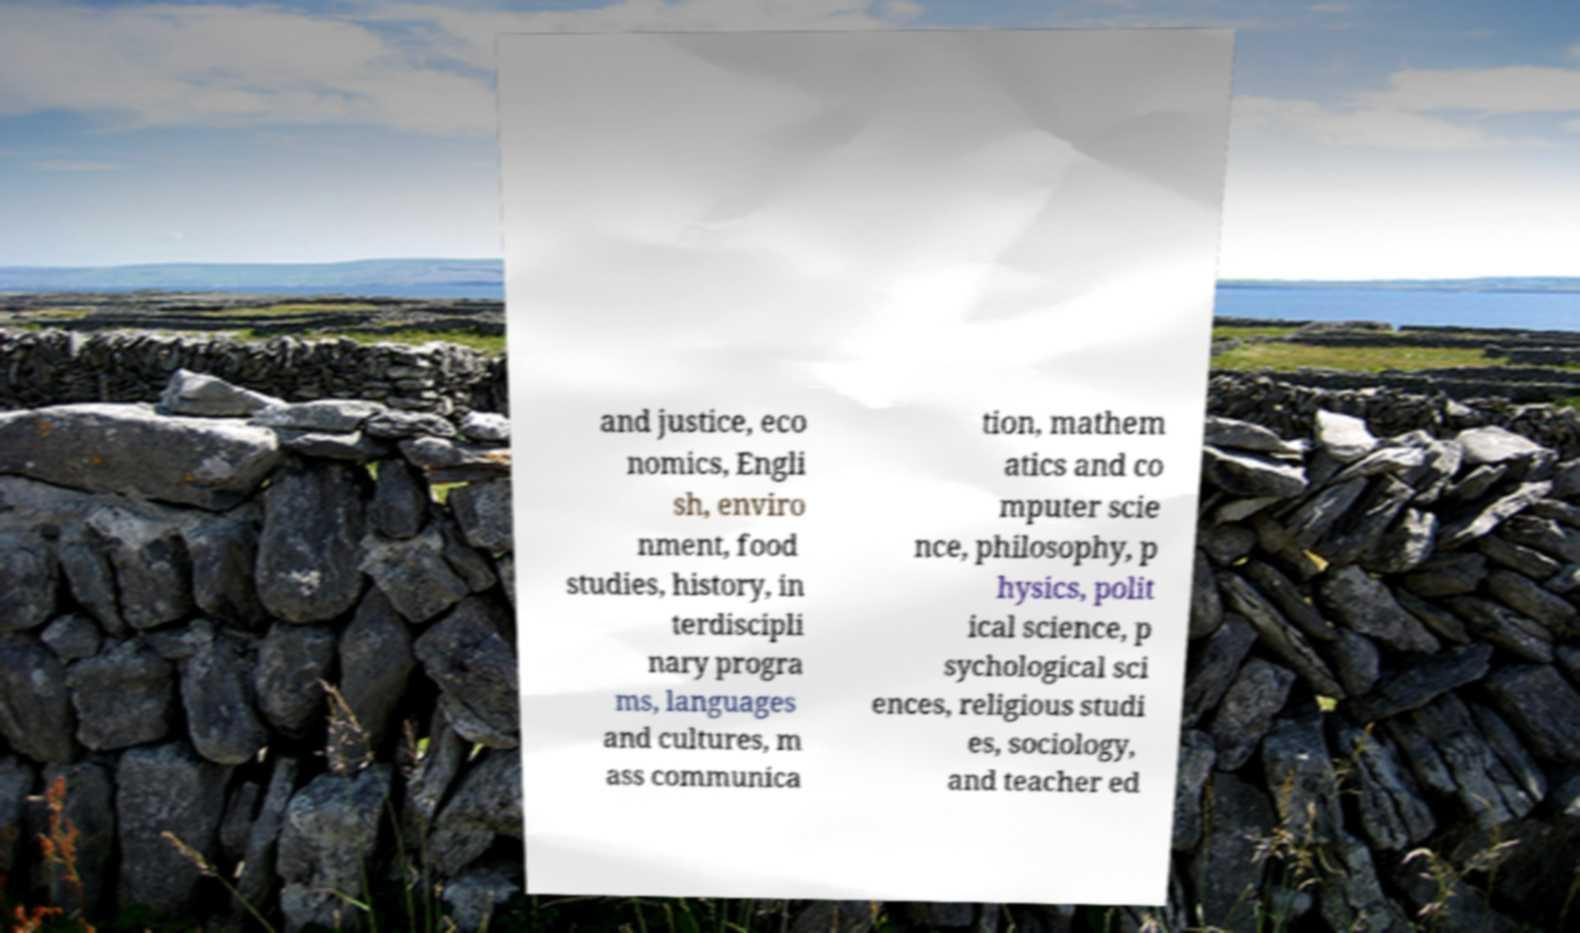Can you accurately transcribe the text from the provided image for me? and justice, eco nomics, Engli sh, enviro nment, food studies, history, in terdiscipli nary progra ms, languages and cultures, m ass communica tion, mathem atics and co mputer scie nce, philosophy, p hysics, polit ical science, p sychological sci ences, religious studi es, sociology, and teacher ed 